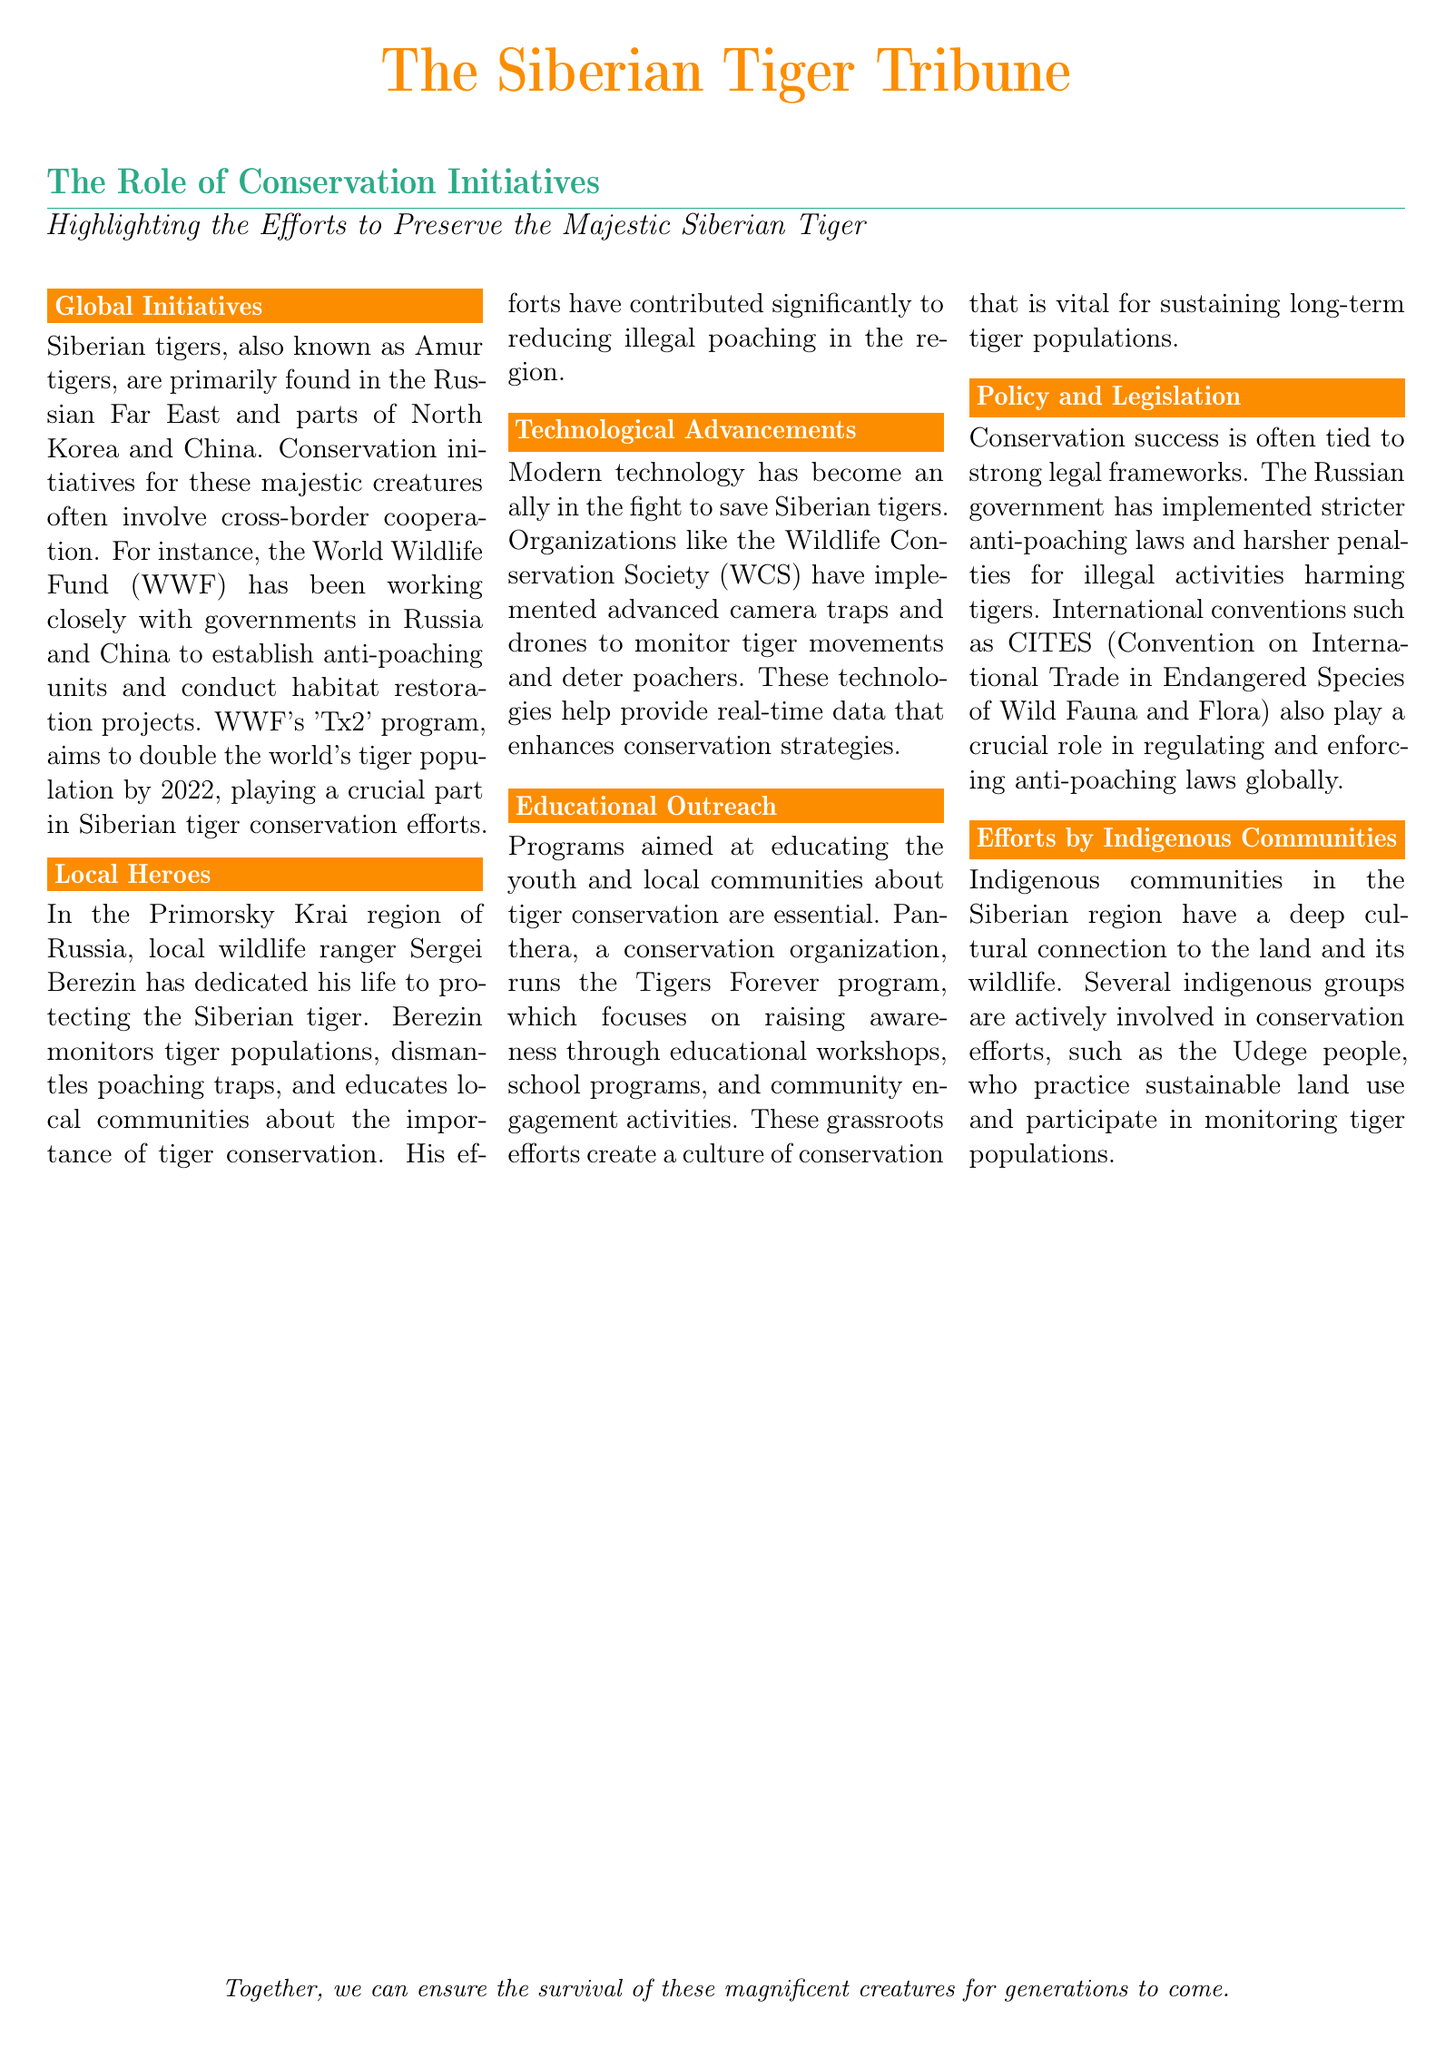what is the main goal of WWF's 'Tx2' program? The document states that WWF's 'Tx2' program aims to double the world's tiger population by 2022.
Answer: double the world's tiger population by 2022 who is a local hero in the Primorsky Krai region? The document mentions Sergei Berezin as a local wildlife ranger dedicated to protecting the Siberian tiger.
Answer: Sergei Berezin what technology does the Wildlife Conservation Society use? The document indicates that the Wildlife Conservation Society implements advanced camera traps and drones.
Answer: advanced camera traps and drones which program does Panthera run? Panthera runs the Tigers Forever program, which focuses on educational outreach.
Answer: Tigers Forever program what role do indigenous communities play in conservation? According to the document, indigenous communities, such as the Udege people, are actively involved in conservation efforts.
Answer: actively involved in conservation efforts what has the Russian government implemented to aid conservation? The document states that the Russian government has implemented stricter anti-poaching laws.
Answer: stricter anti-poaching laws how many columns does the document use? The document is formatted into three columns.
Answer: three columns what type of document is 'The Siberian Tiger Tribune'? The document is a newspaper layout focusing on conservation initiatives.
Answer: newspaper layout 